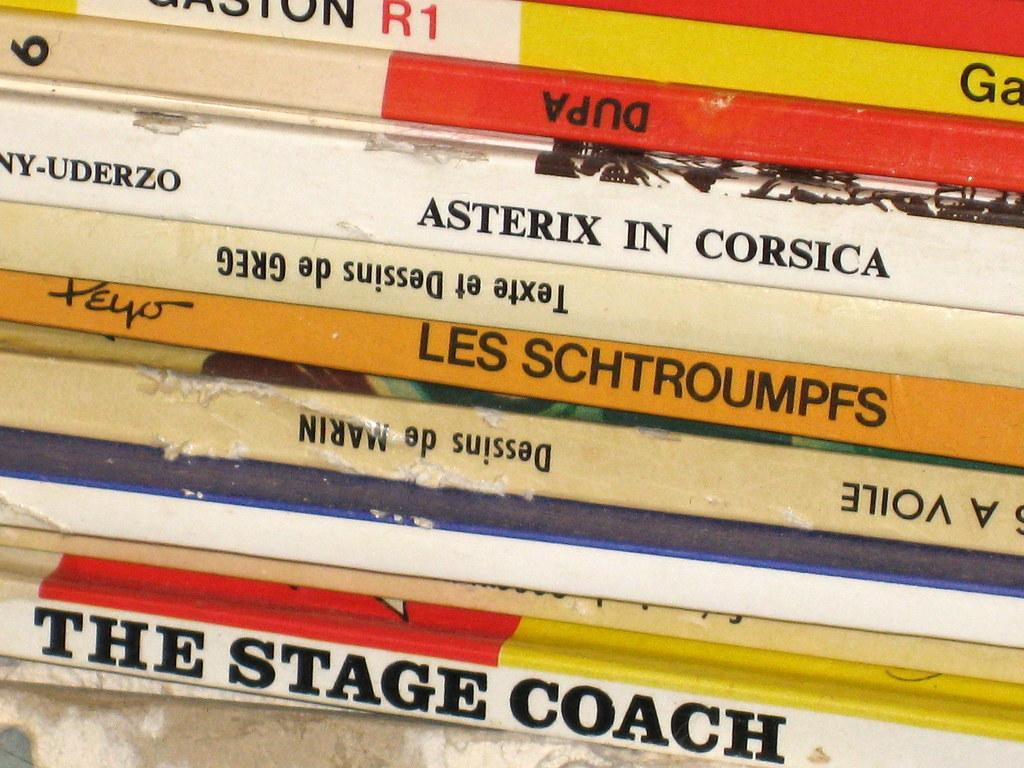<image>
Share a concise interpretation of the image provided. A stack of books including one titled "The Stage Coach" is displayed. 